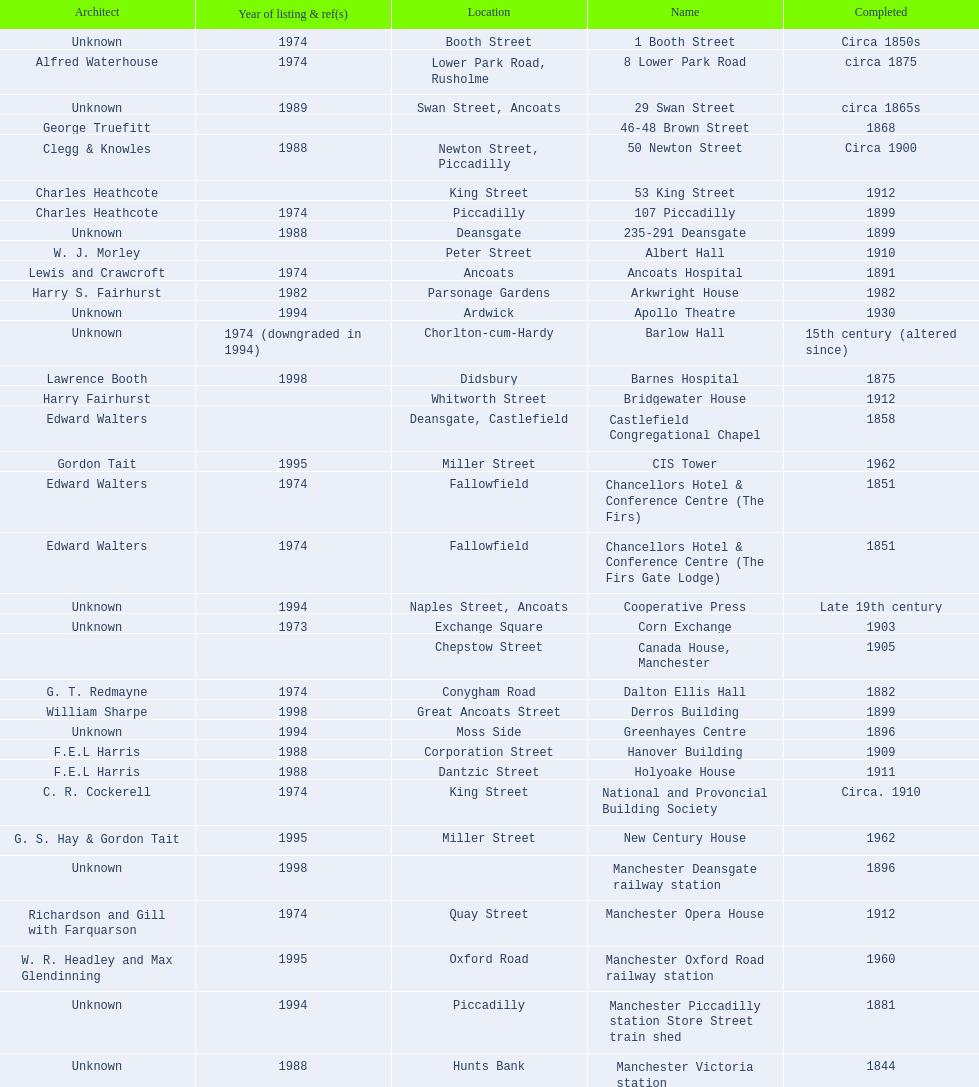Was charles heathcote the architect of ancoats hospital and apollo theatre? No. Write the full table. {'header': ['Architect', 'Year of listing & ref(s)', 'Location', 'Name', 'Completed'], 'rows': [['Unknown', '1974', 'Booth Street', '1 Booth Street', 'Circa 1850s'], ['Alfred Waterhouse', '1974', 'Lower Park Road, Rusholme', '8 Lower Park Road', 'circa 1875'], ['Unknown', '1989', 'Swan Street, Ancoats', '29 Swan Street', 'circa 1865s'], ['George Truefitt', '', '', '46-48 Brown Street', '1868'], ['Clegg & Knowles', '1988', 'Newton Street, Piccadilly', '50 Newton Street', 'Circa 1900'], ['Charles Heathcote', '', 'King Street', '53 King Street', '1912'], ['Charles Heathcote', '1974', 'Piccadilly', '107 Piccadilly', '1899'], ['Unknown', '1988', 'Deansgate', '235-291 Deansgate', '1899'], ['W. J. Morley', '', 'Peter Street', 'Albert Hall', '1910'], ['Lewis and Crawcroft', '1974', 'Ancoats', 'Ancoats Hospital', '1891'], ['Harry S. Fairhurst', '1982', 'Parsonage Gardens', 'Arkwright House', '1982'], ['Unknown', '1994', 'Ardwick', 'Apollo Theatre', '1930'], ['Unknown', '1974 (downgraded in 1994)', 'Chorlton-cum-Hardy', 'Barlow Hall', '15th century (altered since)'], ['Lawrence Booth', '1998', 'Didsbury', 'Barnes Hospital', '1875'], ['Harry Fairhurst', '', 'Whitworth Street', 'Bridgewater House', '1912'], ['Edward Walters', '', 'Deansgate, Castlefield', 'Castlefield Congregational Chapel', '1858'], ['Gordon Tait', '1995', 'Miller Street', 'CIS Tower', '1962'], ['Edward Walters', '1974', 'Fallowfield', 'Chancellors Hotel & Conference Centre (The Firs)', '1851'], ['Edward Walters', '1974', 'Fallowfield', 'Chancellors Hotel & Conference Centre (The Firs Gate Lodge)', '1851'], ['Unknown', '1994', 'Naples Street, Ancoats', 'Cooperative Press', 'Late 19th century'], ['Unknown', '1973', 'Exchange Square', 'Corn Exchange', '1903'], ['', '', 'Chepstow Street', 'Canada House, Manchester', '1905'], ['G. T. Redmayne', '1974', 'Conygham Road', 'Dalton Ellis Hall', '1882'], ['William Sharpe', '1998', 'Great Ancoats Street', 'Derros Building', '1899'], ['Unknown', '1994', 'Moss Side', 'Greenhayes Centre', '1896'], ['F.E.L Harris', '1988', 'Corporation Street', 'Hanover Building', '1909'], ['F.E.L Harris', '1988', 'Dantzic Street', 'Holyoake House', '1911'], ['C. R. Cockerell', '1974', 'King Street', 'National and Provoncial Building Society', 'Circa. 1910'], ['G. S. Hay & Gordon Tait', '1995', 'Miller Street', 'New Century House', '1962'], ['Unknown', '1998', '', 'Manchester Deansgate railway station', '1896'], ['Richardson and Gill with Farquarson', '1974', 'Quay Street', 'Manchester Opera House', '1912'], ['W. R. Headley and Max Glendinning', '1995', 'Oxford Road', 'Manchester Oxford Road railway station', '1960'], ['Unknown', '1994', 'Piccadilly', 'Manchester Piccadilly station Store Street train shed', '1881'], ['Unknown', '1988', 'Hunts Bank', 'Manchester Victoria station', '1844'], ['Alfred Derbyshire and F.Bennett Smith', '1977', 'Oxford Street', 'Palace Theatre', '1891'], ['Unknown', '1994', 'Whitworth Street', 'The Ritz', '1927'], ['Bradshaw, Gass & Hope', '', 'Cross Street', 'Royal Exchange', '1921'], ['W. A. Johnson and J. W. Cooper', '1994', 'Dantzic Street', 'Redfern Building', '1936'], ['Spalding and Cross', '1974', 'Sackville Street', 'Sackville Street Building', '1912'], ['Clegg, Fryer & Penman', '1988', '65-95 Oxford Street', 'St. James Buildings', '1912'], ['John Ely', '1994', 'Wilmslow Road', "St Mary's Hospital", '1909'], ['Percy Scott Worthington', '2010', 'Oxford Road', 'Samuel Alexander Building', '1919'], ['Harry S. Fairhurst', '1982', 'King Street', 'Ship Canal House', '1927'], ['Unknown', '1973', 'Swan Street, Ancoats', 'Smithfield Market Hall', '1857'], ['Alfred Waterhouse', '1974', 'Sherborne Street', 'Strangeways Gaol Gatehouse', '1868'], ['Alfred Waterhouse', '1974', 'Sherborne Street', 'Strangeways Prison ventilation and watch tower', '1868'], ['Irwin and Chester', '1974', 'Peter Street', 'Theatre Royal', '1845'], ['L. C. Howitt', '1999', 'Fallowfield', 'Toast Rack', '1960'], ['Unknown', '1952', 'Shambles Square', 'The Old Wellington Inn', 'Mid-16th century'], ['Unknown', '1974', 'Whitworth Park', 'Whitworth Park Mansions', 'Circa 1840s']]} 